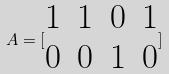<formula> <loc_0><loc_0><loc_500><loc_500>A = [ \begin{matrix} 1 & 1 & 0 & 1 \\ 0 & 0 & 1 & 0 \end{matrix} ]</formula> 